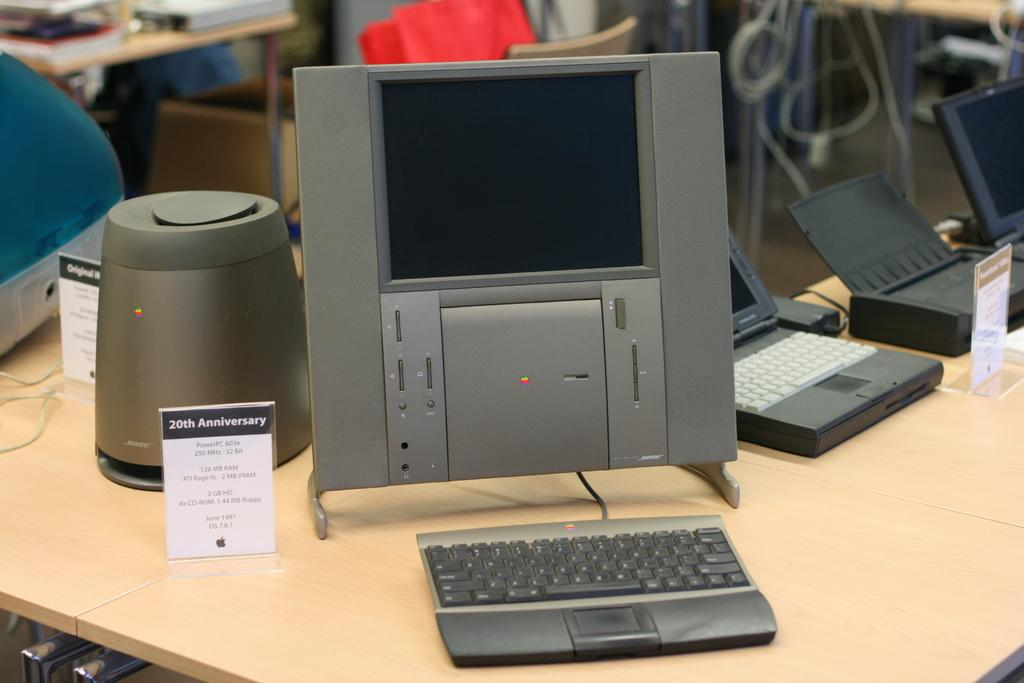<image>
Describe the image concisely. A store display of an apple computer and keyboard in grey. 